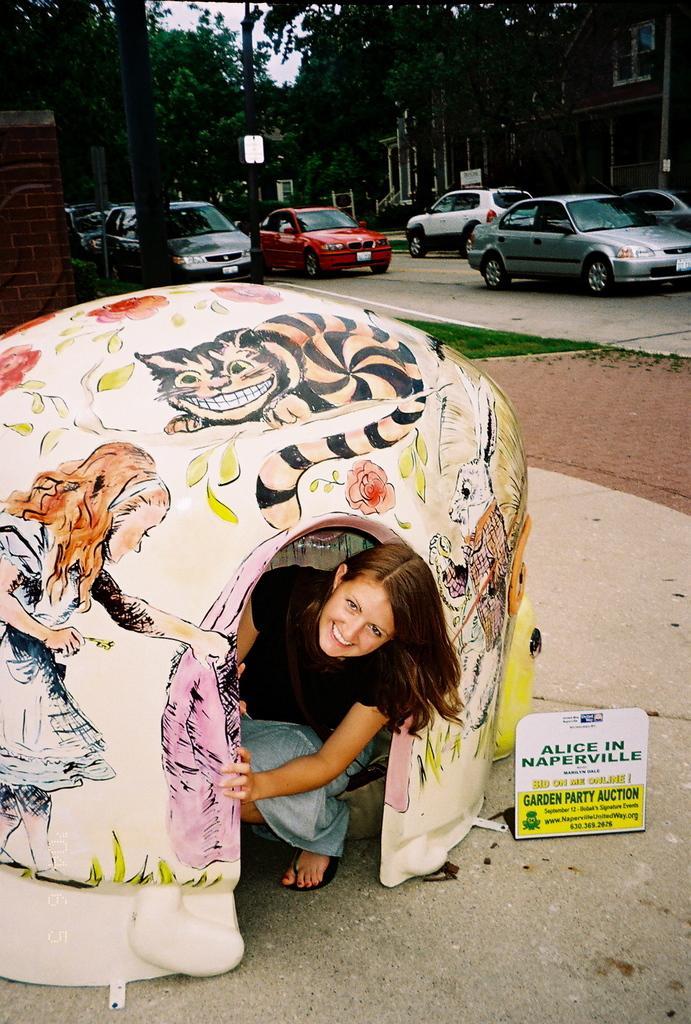In one or two sentences, can you explain what this image depicts? In this image I can see there is a woman sitting inside the tent and there are few trees, poles, vehicles and buildings in the background and the sky is clear. 